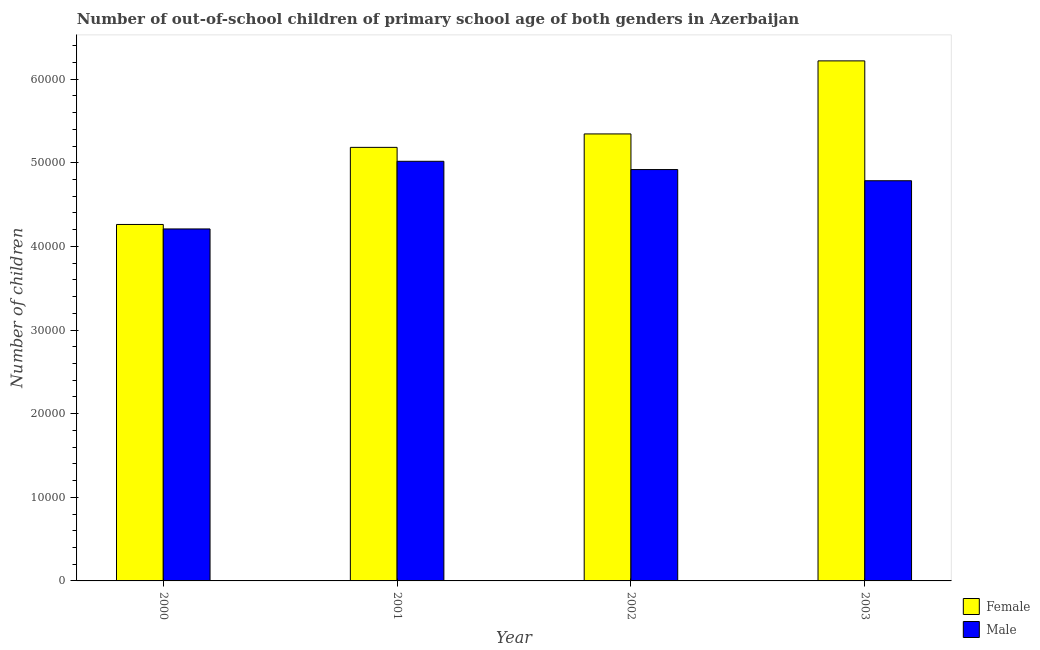How many different coloured bars are there?
Your answer should be compact. 2. How many bars are there on the 4th tick from the right?
Ensure brevity in your answer.  2. What is the label of the 1st group of bars from the left?
Keep it short and to the point. 2000. What is the number of female out-of-school students in 2001?
Your answer should be compact. 5.18e+04. Across all years, what is the maximum number of female out-of-school students?
Make the answer very short. 6.22e+04. Across all years, what is the minimum number of male out-of-school students?
Make the answer very short. 4.21e+04. What is the total number of female out-of-school students in the graph?
Give a very brief answer. 2.10e+05. What is the difference between the number of male out-of-school students in 2000 and that in 2002?
Your answer should be compact. -7101. What is the difference between the number of female out-of-school students in 2000 and the number of male out-of-school students in 2003?
Your response must be concise. -1.96e+04. What is the average number of female out-of-school students per year?
Your answer should be very brief. 5.25e+04. In how many years, is the number of male out-of-school students greater than 56000?
Ensure brevity in your answer.  0. What is the ratio of the number of male out-of-school students in 2001 to that in 2003?
Your response must be concise. 1.05. Is the difference between the number of male out-of-school students in 2001 and 2003 greater than the difference between the number of female out-of-school students in 2001 and 2003?
Your answer should be compact. No. What is the difference between the highest and the second highest number of female out-of-school students?
Your response must be concise. 8735. What is the difference between the highest and the lowest number of male out-of-school students?
Keep it short and to the point. 8090. In how many years, is the number of male out-of-school students greater than the average number of male out-of-school students taken over all years?
Your answer should be very brief. 3. What does the 1st bar from the left in 2002 represents?
Your response must be concise. Female. Are all the bars in the graph horizontal?
Ensure brevity in your answer.  No. How many years are there in the graph?
Ensure brevity in your answer.  4. What is the difference between two consecutive major ticks on the Y-axis?
Your answer should be compact. 10000. Are the values on the major ticks of Y-axis written in scientific E-notation?
Your answer should be compact. No. Does the graph contain any zero values?
Your response must be concise. No. How many legend labels are there?
Offer a terse response. 2. How are the legend labels stacked?
Provide a short and direct response. Vertical. What is the title of the graph?
Provide a short and direct response. Number of out-of-school children of primary school age of both genders in Azerbaijan. Does "% of GNI" appear as one of the legend labels in the graph?
Your answer should be very brief. No. What is the label or title of the X-axis?
Make the answer very short. Year. What is the label or title of the Y-axis?
Provide a succinct answer. Number of children. What is the Number of children in Female in 2000?
Ensure brevity in your answer.  4.26e+04. What is the Number of children in Male in 2000?
Offer a terse response. 4.21e+04. What is the Number of children of Female in 2001?
Provide a succinct answer. 5.18e+04. What is the Number of children of Male in 2001?
Your answer should be compact. 5.02e+04. What is the Number of children of Female in 2002?
Provide a short and direct response. 5.34e+04. What is the Number of children of Male in 2002?
Your response must be concise. 4.92e+04. What is the Number of children of Female in 2003?
Your response must be concise. 6.22e+04. What is the Number of children of Male in 2003?
Give a very brief answer. 4.78e+04. Across all years, what is the maximum Number of children of Female?
Offer a terse response. 6.22e+04. Across all years, what is the maximum Number of children in Male?
Ensure brevity in your answer.  5.02e+04. Across all years, what is the minimum Number of children in Female?
Provide a short and direct response. 4.26e+04. Across all years, what is the minimum Number of children of Male?
Your response must be concise. 4.21e+04. What is the total Number of children of Female in the graph?
Offer a very short reply. 2.10e+05. What is the total Number of children of Male in the graph?
Your answer should be very brief. 1.89e+05. What is the difference between the Number of children in Female in 2000 and that in 2001?
Ensure brevity in your answer.  -9217. What is the difference between the Number of children in Male in 2000 and that in 2001?
Your response must be concise. -8090. What is the difference between the Number of children of Female in 2000 and that in 2002?
Provide a succinct answer. -1.08e+04. What is the difference between the Number of children in Male in 2000 and that in 2002?
Ensure brevity in your answer.  -7101. What is the difference between the Number of children of Female in 2000 and that in 2003?
Offer a very short reply. -1.96e+04. What is the difference between the Number of children of Male in 2000 and that in 2003?
Your response must be concise. -5763. What is the difference between the Number of children of Female in 2001 and that in 2002?
Your response must be concise. -1607. What is the difference between the Number of children in Male in 2001 and that in 2002?
Offer a very short reply. 989. What is the difference between the Number of children in Female in 2001 and that in 2003?
Your answer should be compact. -1.03e+04. What is the difference between the Number of children in Male in 2001 and that in 2003?
Give a very brief answer. 2327. What is the difference between the Number of children in Female in 2002 and that in 2003?
Offer a terse response. -8735. What is the difference between the Number of children of Male in 2002 and that in 2003?
Keep it short and to the point. 1338. What is the difference between the Number of children of Female in 2000 and the Number of children of Male in 2001?
Make the answer very short. -7554. What is the difference between the Number of children of Female in 2000 and the Number of children of Male in 2002?
Provide a short and direct response. -6565. What is the difference between the Number of children in Female in 2000 and the Number of children in Male in 2003?
Offer a terse response. -5227. What is the difference between the Number of children of Female in 2001 and the Number of children of Male in 2002?
Your response must be concise. 2652. What is the difference between the Number of children in Female in 2001 and the Number of children in Male in 2003?
Offer a very short reply. 3990. What is the difference between the Number of children in Female in 2002 and the Number of children in Male in 2003?
Keep it short and to the point. 5597. What is the average Number of children in Female per year?
Your answer should be compact. 5.25e+04. What is the average Number of children in Male per year?
Your answer should be compact. 4.73e+04. In the year 2000, what is the difference between the Number of children of Female and Number of children of Male?
Your answer should be very brief. 536. In the year 2001, what is the difference between the Number of children in Female and Number of children in Male?
Your answer should be very brief. 1663. In the year 2002, what is the difference between the Number of children in Female and Number of children in Male?
Your answer should be compact. 4259. In the year 2003, what is the difference between the Number of children in Female and Number of children in Male?
Your answer should be compact. 1.43e+04. What is the ratio of the Number of children of Female in 2000 to that in 2001?
Offer a very short reply. 0.82. What is the ratio of the Number of children in Male in 2000 to that in 2001?
Offer a terse response. 0.84. What is the ratio of the Number of children in Female in 2000 to that in 2002?
Your answer should be very brief. 0.8. What is the ratio of the Number of children in Male in 2000 to that in 2002?
Provide a succinct answer. 0.86. What is the ratio of the Number of children in Female in 2000 to that in 2003?
Keep it short and to the point. 0.69. What is the ratio of the Number of children of Male in 2000 to that in 2003?
Offer a terse response. 0.88. What is the ratio of the Number of children in Female in 2001 to that in 2002?
Your answer should be compact. 0.97. What is the ratio of the Number of children of Male in 2001 to that in 2002?
Your response must be concise. 1.02. What is the ratio of the Number of children of Female in 2001 to that in 2003?
Your response must be concise. 0.83. What is the ratio of the Number of children in Male in 2001 to that in 2003?
Offer a terse response. 1.05. What is the ratio of the Number of children of Female in 2002 to that in 2003?
Provide a succinct answer. 0.86. What is the ratio of the Number of children of Male in 2002 to that in 2003?
Keep it short and to the point. 1.03. What is the difference between the highest and the second highest Number of children in Female?
Make the answer very short. 8735. What is the difference between the highest and the second highest Number of children of Male?
Your response must be concise. 989. What is the difference between the highest and the lowest Number of children in Female?
Provide a succinct answer. 1.96e+04. What is the difference between the highest and the lowest Number of children in Male?
Make the answer very short. 8090. 